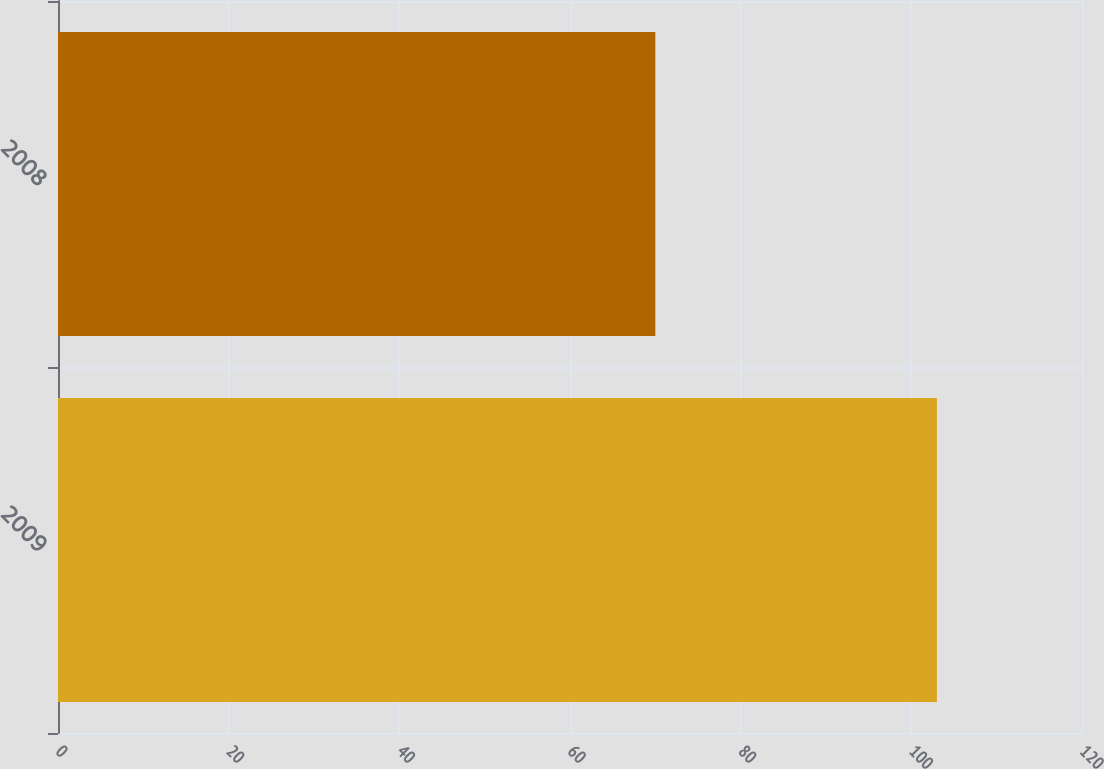Convert chart. <chart><loc_0><loc_0><loc_500><loc_500><bar_chart><fcel>2009<fcel>2008<nl><fcel>103<fcel>70<nl></chart> 